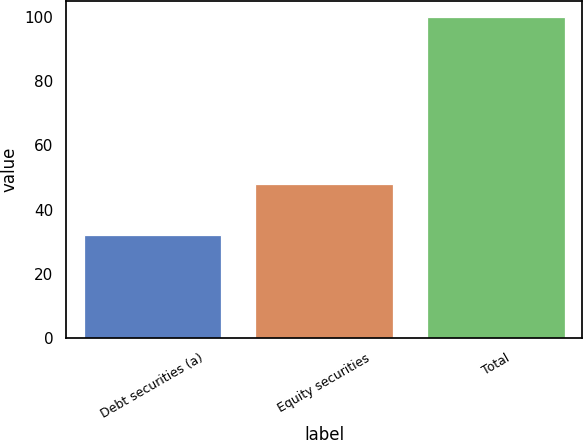Convert chart. <chart><loc_0><loc_0><loc_500><loc_500><bar_chart><fcel>Debt securities (a)<fcel>Equity securities<fcel>Total<nl><fcel>32<fcel>48<fcel>100<nl></chart> 